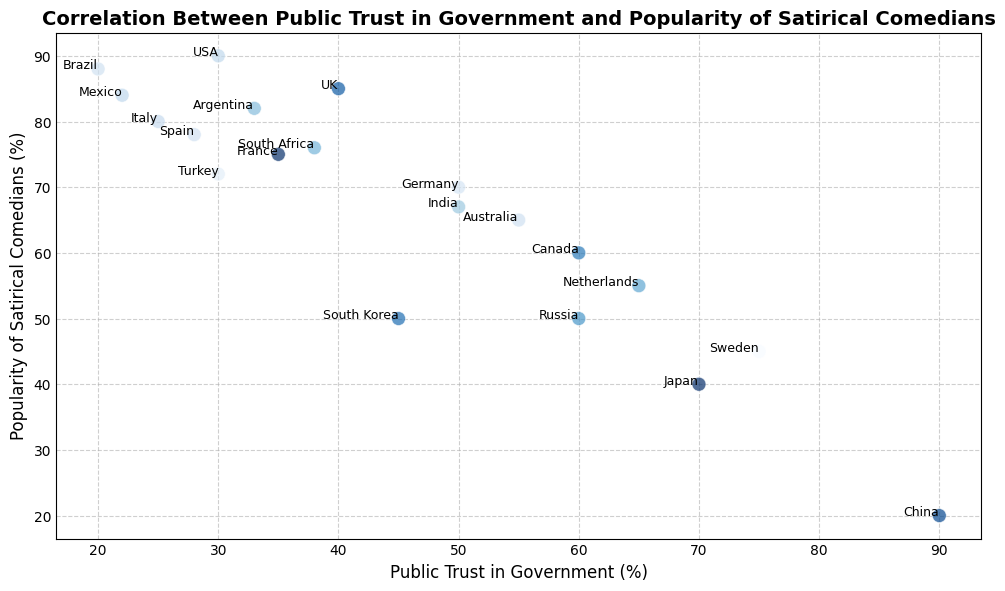Which country has the highest public trust in government? By examining the figure, look for the country plotted at the highest x-axis value. This represents the highest public trust in government.
Answer: China Which country shows the lowest popularity of satirical comedians? By examining the figure, look for the country plotted at the lowest y-axis value. This represents the lowest popularity of satirical comedians.
Answer: China Is there any country with a public trust in government lower than 30% but a popularity of satirical comedians higher than 80%? Look for points where the x-axis value is less than 30 while the y-axis value is above 80, and identify the country associated with that point. In the figure, this condition is met by Brazil.
Answer: Brazil What's the average public trust in government among countries with the popularity of satirical comedians above 75%? Identify the points with y-axis values above 75%, then calculate the average of the corresponding x-axis values: (30 + 25 + 28 + 33 + 20 + 22) / 6 = 26.33
Answer: 26.33 Is there a visual trend indicating a relationship between public trust in government and the popularity of satirical comedians? Visually examine the scatter plot to see if there is a noticeable pattern or trend in the direction of points. The relationship shows a general trend where higher public trust in government often correlates with lower popularity of satirical comedians, and vice versa.
Answer: Inverse correlation Which country has the closest relationship between public trust in government and popularity of satirical comedians (as close to the same value on both axes)? Compare the points where x-axis and y-axis values are close to each other and identify the country. The point closest to this condition is Canada, with values of 60% trust and 60% popularity.
Answer: Canada How many countries have both public trust in government and popularity of satirical comedians above 50%? Count the points in the plot where both x-axis and y-axis values are above 50. Only Germany and Sweden meet this condition.
Answer: 2 Which countries have a higher public trust in government than Turkey? Find Turkey's x-axis value (30%), then identify all points with higher x-axis values, and note the country names: UK, Germany, Canada, Australia, Japan, South Korea, Netherlands, Sweden, Russia, China.
Answer: UK, Germany, Canada, Australia, Japan, South Korea, Netherlands, Sweden, Russia, China 